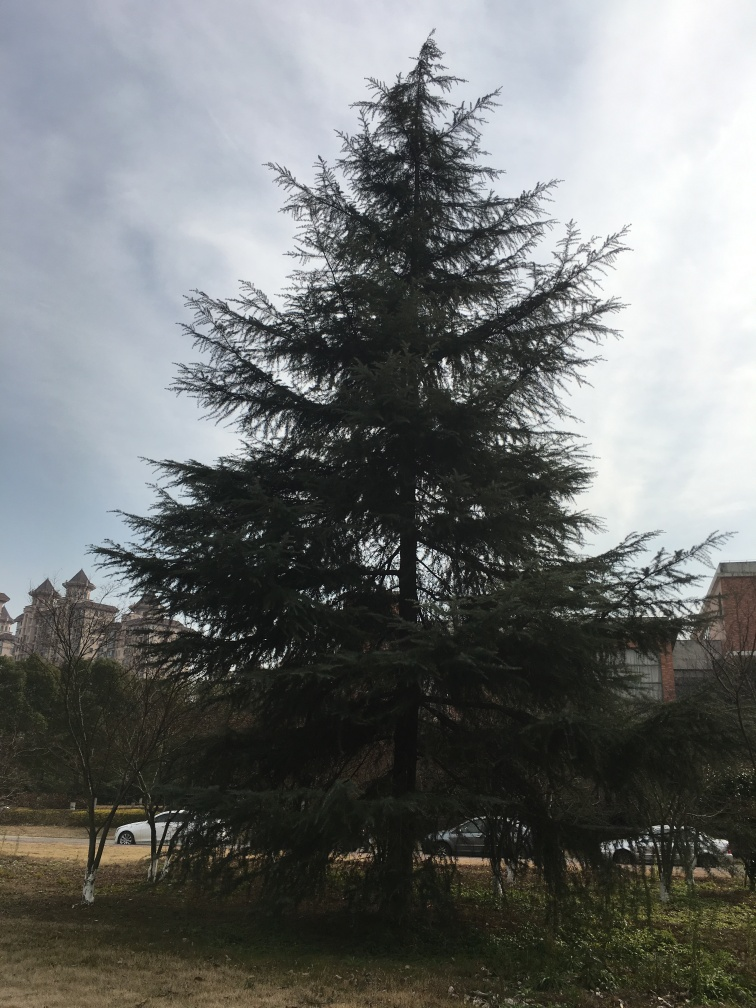Can you describe the mood of the scene? The scene evokes a sense of tranquility and quietude. The large, lush tree juxtaposed against a peaceful sky suggests a calm day, possibly in a serene park or a quiet suburb. Would this setting be suitable for recreational activities? Yes, the open space around the tree and the softness of the grass would make it an ideal spot for various recreational activities like picnicking, reading, or simply enjoying a moment of relaxation. 